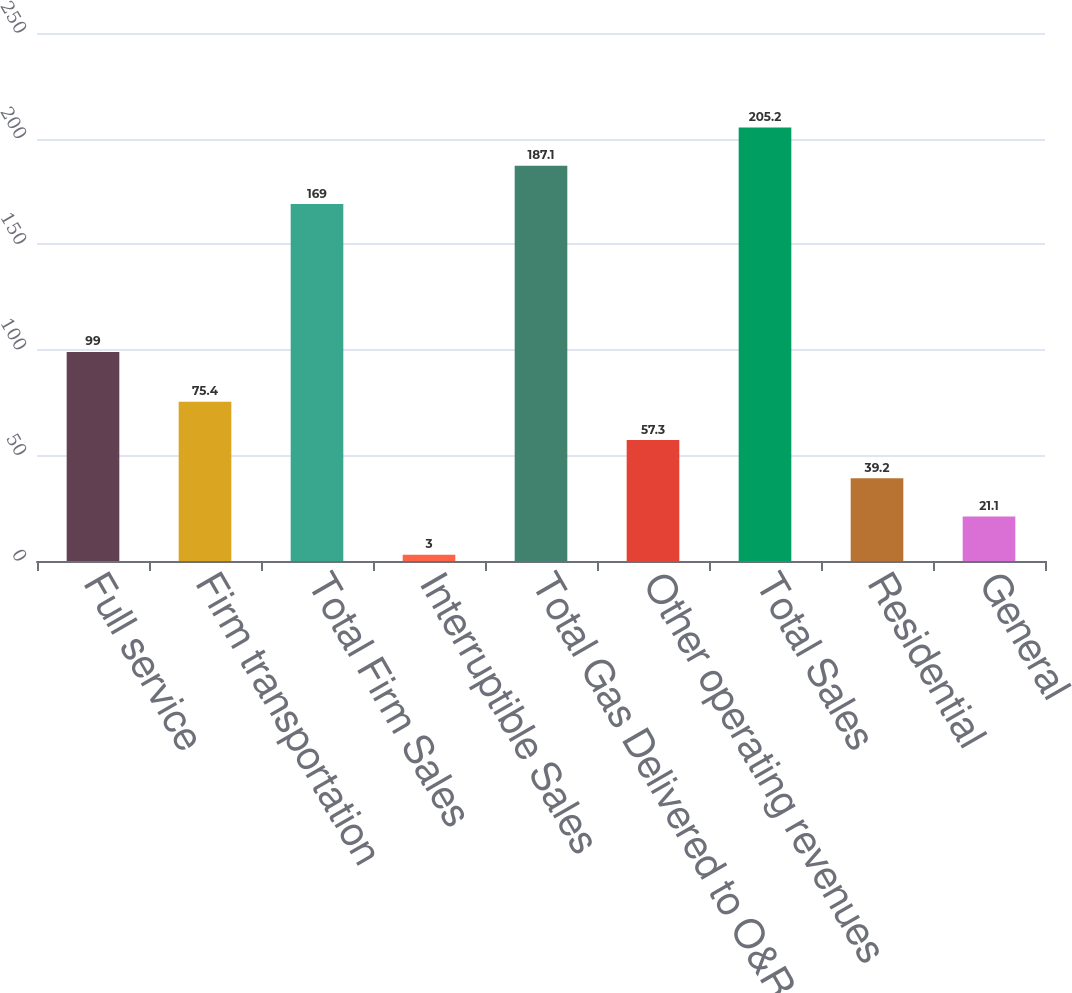Convert chart to OTSL. <chart><loc_0><loc_0><loc_500><loc_500><bar_chart><fcel>Full service<fcel>Firm transportation<fcel>Total Firm Sales<fcel>Interruptible Sales<fcel>Total Gas Delivered to O&R<fcel>Other operating revenues<fcel>Total Sales<fcel>Residential<fcel>General<nl><fcel>99<fcel>75.4<fcel>169<fcel>3<fcel>187.1<fcel>57.3<fcel>205.2<fcel>39.2<fcel>21.1<nl></chart> 